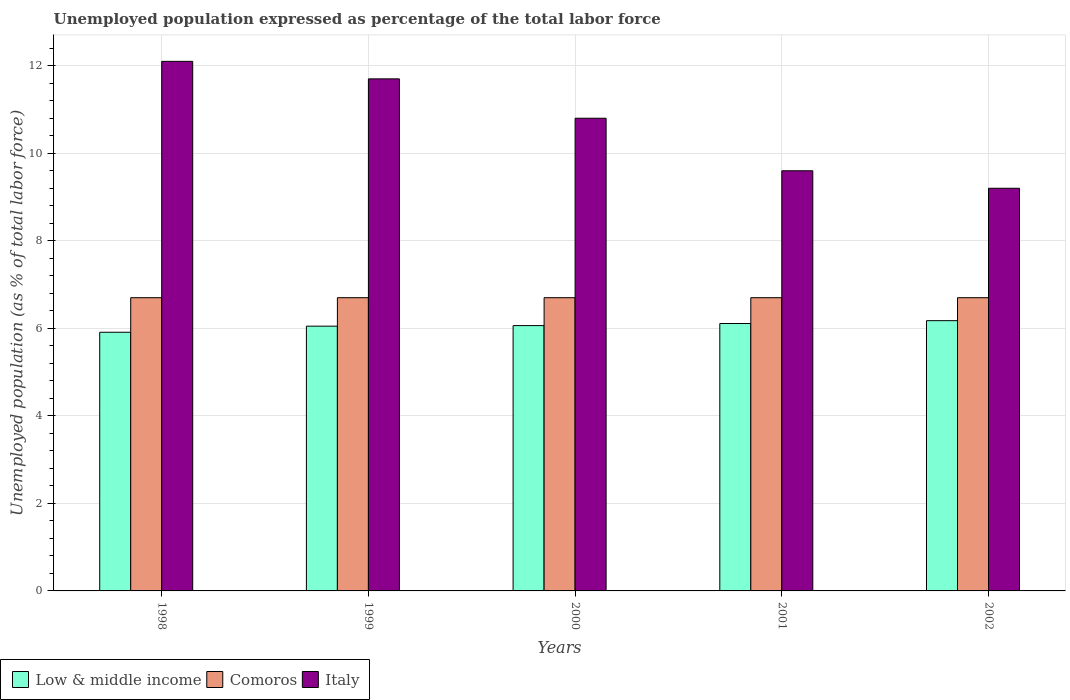Are the number of bars per tick equal to the number of legend labels?
Keep it short and to the point. Yes. How many bars are there on the 5th tick from the left?
Give a very brief answer. 3. How many bars are there on the 2nd tick from the right?
Ensure brevity in your answer.  3. What is the label of the 4th group of bars from the left?
Your answer should be very brief. 2001. What is the unemployment in in Italy in 2001?
Your answer should be very brief. 9.6. Across all years, what is the maximum unemployment in in Italy?
Offer a very short reply. 12.1. Across all years, what is the minimum unemployment in in Low & middle income?
Provide a succinct answer. 5.91. In which year was the unemployment in in Low & middle income minimum?
Ensure brevity in your answer.  1998. What is the total unemployment in in Low & middle income in the graph?
Give a very brief answer. 30.31. What is the difference between the unemployment in in Italy in 1999 and that in 2000?
Provide a short and direct response. 0.9. What is the difference between the unemployment in in Low & middle income in 2001 and the unemployment in in Italy in 2002?
Ensure brevity in your answer.  -3.09. What is the average unemployment in in Low & middle income per year?
Provide a succinct answer. 6.06. In the year 2000, what is the difference between the unemployment in in Comoros and unemployment in in Italy?
Make the answer very short. -4.1. What is the ratio of the unemployment in in Italy in 1998 to that in 2002?
Provide a succinct answer. 1.32. Is the unemployment in in Comoros in 2001 less than that in 2002?
Provide a short and direct response. No. Is the difference between the unemployment in in Comoros in 1998 and 2001 greater than the difference between the unemployment in in Italy in 1998 and 2001?
Make the answer very short. No. What is the difference between the highest and the lowest unemployment in in Low & middle income?
Make the answer very short. 0.26. Is the sum of the unemployment in in Italy in 2001 and 2002 greater than the maximum unemployment in in Low & middle income across all years?
Keep it short and to the point. Yes. What does the 3rd bar from the left in 2000 represents?
Ensure brevity in your answer.  Italy. Is it the case that in every year, the sum of the unemployment in in Comoros and unemployment in in Italy is greater than the unemployment in in Low & middle income?
Your answer should be compact. Yes. How many years are there in the graph?
Keep it short and to the point. 5. Does the graph contain grids?
Offer a very short reply. Yes. Where does the legend appear in the graph?
Give a very brief answer. Bottom left. How are the legend labels stacked?
Keep it short and to the point. Horizontal. What is the title of the graph?
Your answer should be very brief. Unemployed population expressed as percentage of the total labor force. Does "Georgia" appear as one of the legend labels in the graph?
Keep it short and to the point. No. What is the label or title of the X-axis?
Offer a terse response. Years. What is the label or title of the Y-axis?
Your response must be concise. Unemployed population (as % of total labor force). What is the Unemployed population (as % of total labor force) of Low & middle income in 1998?
Give a very brief answer. 5.91. What is the Unemployed population (as % of total labor force) of Comoros in 1998?
Ensure brevity in your answer.  6.7. What is the Unemployed population (as % of total labor force) in Italy in 1998?
Ensure brevity in your answer.  12.1. What is the Unemployed population (as % of total labor force) of Low & middle income in 1999?
Your answer should be very brief. 6.05. What is the Unemployed population (as % of total labor force) of Comoros in 1999?
Provide a short and direct response. 6.7. What is the Unemployed population (as % of total labor force) of Italy in 1999?
Make the answer very short. 11.7. What is the Unemployed population (as % of total labor force) of Low & middle income in 2000?
Make the answer very short. 6.06. What is the Unemployed population (as % of total labor force) in Comoros in 2000?
Offer a very short reply. 6.7. What is the Unemployed population (as % of total labor force) in Italy in 2000?
Offer a terse response. 10.8. What is the Unemployed population (as % of total labor force) of Low & middle income in 2001?
Offer a terse response. 6.11. What is the Unemployed population (as % of total labor force) in Comoros in 2001?
Provide a short and direct response. 6.7. What is the Unemployed population (as % of total labor force) in Italy in 2001?
Offer a terse response. 9.6. What is the Unemployed population (as % of total labor force) of Low & middle income in 2002?
Make the answer very short. 6.18. What is the Unemployed population (as % of total labor force) of Comoros in 2002?
Give a very brief answer. 6.7. What is the Unemployed population (as % of total labor force) in Italy in 2002?
Provide a succinct answer. 9.2. Across all years, what is the maximum Unemployed population (as % of total labor force) of Low & middle income?
Ensure brevity in your answer.  6.18. Across all years, what is the maximum Unemployed population (as % of total labor force) of Comoros?
Offer a very short reply. 6.7. Across all years, what is the maximum Unemployed population (as % of total labor force) in Italy?
Keep it short and to the point. 12.1. Across all years, what is the minimum Unemployed population (as % of total labor force) of Low & middle income?
Give a very brief answer. 5.91. Across all years, what is the minimum Unemployed population (as % of total labor force) of Comoros?
Keep it short and to the point. 6.7. Across all years, what is the minimum Unemployed population (as % of total labor force) in Italy?
Give a very brief answer. 9.2. What is the total Unemployed population (as % of total labor force) in Low & middle income in the graph?
Ensure brevity in your answer.  30.31. What is the total Unemployed population (as % of total labor force) of Comoros in the graph?
Your response must be concise. 33.5. What is the total Unemployed population (as % of total labor force) of Italy in the graph?
Provide a succinct answer. 53.4. What is the difference between the Unemployed population (as % of total labor force) of Low & middle income in 1998 and that in 1999?
Your answer should be very brief. -0.14. What is the difference between the Unemployed population (as % of total labor force) in Italy in 1998 and that in 1999?
Your answer should be very brief. 0.4. What is the difference between the Unemployed population (as % of total labor force) of Low & middle income in 1998 and that in 2000?
Provide a short and direct response. -0.15. What is the difference between the Unemployed population (as % of total labor force) in Comoros in 1998 and that in 2000?
Give a very brief answer. 0. What is the difference between the Unemployed population (as % of total labor force) of Italy in 1998 and that in 2000?
Offer a very short reply. 1.3. What is the difference between the Unemployed population (as % of total labor force) in Low & middle income in 1998 and that in 2001?
Your answer should be very brief. -0.2. What is the difference between the Unemployed population (as % of total labor force) of Low & middle income in 1998 and that in 2002?
Ensure brevity in your answer.  -0.26. What is the difference between the Unemployed population (as % of total labor force) in Comoros in 1998 and that in 2002?
Your response must be concise. 0. What is the difference between the Unemployed population (as % of total labor force) of Italy in 1998 and that in 2002?
Give a very brief answer. 2.9. What is the difference between the Unemployed population (as % of total labor force) of Low & middle income in 1999 and that in 2000?
Keep it short and to the point. -0.01. What is the difference between the Unemployed population (as % of total labor force) in Low & middle income in 1999 and that in 2001?
Your answer should be very brief. -0.06. What is the difference between the Unemployed population (as % of total labor force) of Comoros in 1999 and that in 2001?
Provide a succinct answer. 0. What is the difference between the Unemployed population (as % of total labor force) in Low & middle income in 1999 and that in 2002?
Your answer should be very brief. -0.13. What is the difference between the Unemployed population (as % of total labor force) of Italy in 1999 and that in 2002?
Provide a short and direct response. 2.5. What is the difference between the Unemployed population (as % of total labor force) of Low & middle income in 2000 and that in 2001?
Provide a succinct answer. -0.05. What is the difference between the Unemployed population (as % of total labor force) in Italy in 2000 and that in 2001?
Keep it short and to the point. 1.2. What is the difference between the Unemployed population (as % of total labor force) in Low & middle income in 2000 and that in 2002?
Offer a very short reply. -0.11. What is the difference between the Unemployed population (as % of total labor force) of Italy in 2000 and that in 2002?
Make the answer very short. 1.6. What is the difference between the Unemployed population (as % of total labor force) of Low & middle income in 2001 and that in 2002?
Offer a terse response. -0.07. What is the difference between the Unemployed population (as % of total labor force) of Low & middle income in 1998 and the Unemployed population (as % of total labor force) of Comoros in 1999?
Offer a terse response. -0.79. What is the difference between the Unemployed population (as % of total labor force) in Low & middle income in 1998 and the Unemployed population (as % of total labor force) in Italy in 1999?
Ensure brevity in your answer.  -5.79. What is the difference between the Unemployed population (as % of total labor force) in Low & middle income in 1998 and the Unemployed population (as % of total labor force) in Comoros in 2000?
Make the answer very short. -0.79. What is the difference between the Unemployed population (as % of total labor force) in Low & middle income in 1998 and the Unemployed population (as % of total labor force) in Italy in 2000?
Keep it short and to the point. -4.89. What is the difference between the Unemployed population (as % of total labor force) in Low & middle income in 1998 and the Unemployed population (as % of total labor force) in Comoros in 2001?
Provide a short and direct response. -0.79. What is the difference between the Unemployed population (as % of total labor force) in Low & middle income in 1998 and the Unemployed population (as % of total labor force) in Italy in 2001?
Give a very brief answer. -3.69. What is the difference between the Unemployed population (as % of total labor force) in Comoros in 1998 and the Unemployed population (as % of total labor force) in Italy in 2001?
Keep it short and to the point. -2.9. What is the difference between the Unemployed population (as % of total labor force) of Low & middle income in 1998 and the Unemployed population (as % of total labor force) of Comoros in 2002?
Your response must be concise. -0.79. What is the difference between the Unemployed population (as % of total labor force) of Low & middle income in 1998 and the Unemployed population (as % of total labor force) of Italy in 2002?
Make the answer very short. -3.29. What is the difference between the Unemployed population (as % of total labor force) of Comoros in 1998 and the Unemployed population (as % of total labor force) of Italy in 2002?
Ensure brevity in your answer.  -2.5. What is the difference between the Unemployed population (as % of total labor force) in Low & middle income in 1999 and the Unemployed population (as % of total labor force) in Comoros in 2000?
Give a very brief answer. -0.65. What is the difference between the Unemployed population (as % of total labor force) in Low & middle income in 1999 and the Unemployed population (as % of total labor force) in Italy in 2000?
Offer a very short reply. -4.75. What is the difference between the Unemployed population (as % of total labor force) of Low & middle income in 1999 and the Unemployed population (as % of total labor force) of Comoros in 2001?
Provide a short and direct response. -0.65. What is the difference between the Unemployed population (as % of total labor force) of Low & middle income in 1999 and the Unemployed population (as % of total labor force) of Italy in 2001?
Make the answer very short. -3.55. What is the difference between the Unemployed population (as % of total labor force) of Comoros in 1999 and the Unemployed population (as % of total labor force) of Italy in 2001?
Provide a succinct answer. -2.9. What is the difference between the Unemployed population (as % of total labor force) in Low & middle income in 1999 and the Unemployed population (as % of total labor force) in Comoros in 2002?
Your answer should be compact. -0.65. What is the difference between the Unemployed population (as % of total labor force) of Low & middle income in 1999 and the Unemployed population (as % of total labor force) of Italy in 2002?
Keep it short and to the point. -3.15. What is the difference between the Unemployed population (as % of total labor force) in Comoros in 1999 and the Unemployed population (as % of total labor force) in Italy in 2002?
Provide a succinct answer. -2.5. What is the difference between the Unemployed population (as % of total labor force) of Low & middle income in 2000 and the Unemployed population (as % of total labor force) of Comoros in 2001?
Ensure brevity in your answer.  -0.64. What is the difference between the Unemployed population (as % of total labor force) of Low & middle income in 2000 and the Unemployed population (as % of total labor force) of Italy in 2001?
Offer a very short reply. -3.54. What is the difference between the Unemployed population (as % of total labor force) of Low & middle income in 2000 and the Unemployed population (as % of total labor force) of Comoros in 2002?
Your response must be concise. -0.64. What is the difference between the Unemployed population (as % of total labor force) of Low & middle income in 2000 and the Unemployed population (as % of total labor force) of Italy in 2002?
Provide a short and direct response. -3.14. What is the difference between the Unemployed population (as % of total labor force) in Low & middle income in 2001 and the Unemployed population (as % of total labor force) in Comoros in 2002?
Offer a very short reply. -0.59. What is the difference between the Unemployed population (as % of total labor force) in Low & middle income in 2001 and the Unemployed population (as % of total labor force) in Italy in 2002?
Provide a short and direct response. -3.09. What is the difference between the Unemployed population (as % of total labor force) in Comoros in 2001 and the Unemployed population (as % of total labor force) in Italy in 2002?
Your answer should be very brief. -2.5. What is the average Unemployed population (as % of total labor force) in Low & middle income per year?
Provide a succinct answer. 6.06. What is the average Unemployed population (as % of total labor force) of Comoros per year?
Provide a succinct answer. 6.7. What is the average Unemployed population (as % of total labor force) of Italy per year?
Provide a succinct answer. 10.68. In the year 1998, what is the difference between the Unemployed population (as % of total labor force) in Low & middle income and Unemployed population (as % of total labor force) in Comoros?
Keep it short and to the point. -0.79. In the year 1998, what is the difference between the Unemployed population (as % of total labor force) in Low & middle income and Unemployed population (as % of total labor force) in Italy?
Offer a very short reply. -6.19. In the year 1999, what is the difference between the Unemployed population (as % of total labor force) in Low & middle income and Unemployed population (as % of total labor force) in Comoros?
Make the answer very short. -0.65. In the year 1999, what is the difference between the Unemployed population (as % of total labor force) in Low & middle income and Unemployed population (as % of total labor force) in Italy?
Make the answer very short. -5.65. In the year 2000, what is the difference between the Unemployed population (as % of total labor force) of Low & middle income and Unemployed population (as % of total labor force) of Comoros?
Provide a succinct answer. -0.64. In the year 2000, what is the difference between the Unemployed population (as % of total labor force) of Low & middle income and Unemployed population (as % of total labor force) of Italy?
Ensure brevity in your answer.  -4.74. In the year 2001, what is the difference between the Unemployed population (as % of total labor force) in Low & middle income and Unemployed population (as % of total labor force) in Comoros?
Offer a very short reply. -0.59. In the year 2001, what is the difference between the Unemployed population (as % of total labor force) of Low & middle income and Unemployed population (as % of total labor force) of Italy?
Your answer should be very brief. -3.49. In the year 2001, what is the difference between the Unemployed population (as % of total labor force) of Comoros and Unemployed population (as % of total labor force) of Italy?
Make the answer very short. -2.9. In the year 2002, what is the difference between the Unemployed population (as % of total labor force) in Low & middle income and Unemployed population (as % of total labor force) in Comoros?
Your response must be concise. -0.52. In the year 2002, what is the difference between the Unemployed population (as % of total labor force) in Low & middle income and Unemployed population (as % of total labor force) in Italy?
Give a very brief answer. -3.02. What is the ratio of the Unemployed population (as % of total labor force) in Italy in 1998 to that in 1999?
Your response must be concise. 1.03. What is the ratio of the Unemployed population (as % of total labor force) in Low & middle income in 1998 to that in 2000?
Provide a short and direct response. 0.97. What is the ratio of the Unemployed population (as % of total labor force) of Comoros in 1998 to that in 2000?
Your response must be concise. 1. What is the ratio of the Unemployed population (as % of total labor force) in Italy in 1998 to that in 2000?
Offer a terse response. 1.12. What is the ratio of the Unemployed population (as % of total labor force) in Low & middle income in 1998 to that in 2001?
Ensure brevity in your answer.  0.97. What is the ratio of the Unemployed population (as % of total labor force) in Italy in 1998 to that in 2001?
Provide a short and direct response. 1.26. What is the ratio of the Unemployed population (as % of total labor force) in Low & middle income in 1998 to that in 2002?
Your answer should be very brief. 0.96. What is the ratio of the Unemployed population (as % of total labor force) in Comoros in 1998 to that in 2002?
Your response must be concise. 1. What is the ratio of the Unemployed population (as % of total labor force) in Italy in 1998 to that in 2002?
Offer a terse response. 1.32. What is the ratio of the Unemployed population (as % of total labor force) in Low & middle income in 1999 to that in 2000?
Offer a very short reply. 1. What is the ratio of the Unemployed population (as % of total labor force) of Italy in 1999 to that in 2001?
Your answer should be very brief. 1.22. What is the ratio of the Unemployed population (as % of total labor force) in Low & middle income in 1999 to that in 2002?
Offer a very short reply. 0.98. What is the ratio of the Unemployed population (as % of total labor force) in Italy in 1999 to that in 2002?
Make the answer very short. 1.27. What is the ratio of the Unemployed population (as % of total labor force) of Low & middle income in 2000 to that in 2001?
Keep it short and to the point. 0.99. What is the ratio of the Unemployed population (as % of total labor force) in Comoros in 2000 to that in 2001?
Offer a very short reply. 1. What is the ratio of the Unemployed population (as % of total labor force) of Italy in 2000 to that in 2001?
Ensure brevity in your answer.  1.12. What is the ratio of the Unemployed population (as % of total labor force) of Low & middle income in 2000 to that in 2002?
Offer a very short reply. 0.98. What is the ratio of the Unemployed population (as % of total labor force) of Italy in 2000 to that in 2002?
Provide a succinct answer. 1.17. What is the ratio of the Unemployed population (as % of total labor force) in Low & middle income in 2001 to that in 2002?
Provide a short and direct response. 0.99. What is the ratio of the Unemployed population (as % of total labor force) of Comoros in 2001 to that in 2002?
Your response must be concise. 1. What is the ratio of the Unemployed population (as % of total labor force) in Italy in 2001 to that in 2002?
Your response must be concise. 1.04. What is the difference between the highest and the second highest Unemployed population (as % of total labor force) in Low & middle income?
Provide a short and direct response. 0.07. What is the difference between the highest and the lowest Unemployed population (as % of total labor force) of Low & middle income?
Your answer should be very brief. 0.26. 